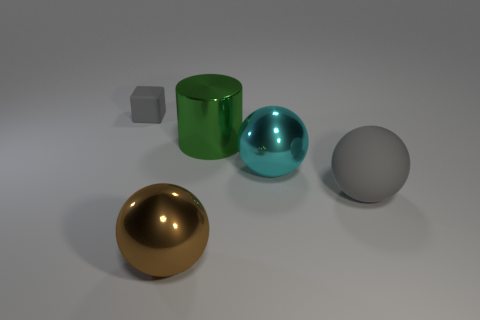Is the color of the thing that is on the left side of the brown shiny thing the same as the matte object in front of the matte cube? The object to the left of the shiny brown sphere appears to be a matte gray cube, and its color is indeed similar to the matte object, a sphere, located in front of the larger matte cube. Both share a shade of gray, although the lighting may affect the perception of their colors slightly. 